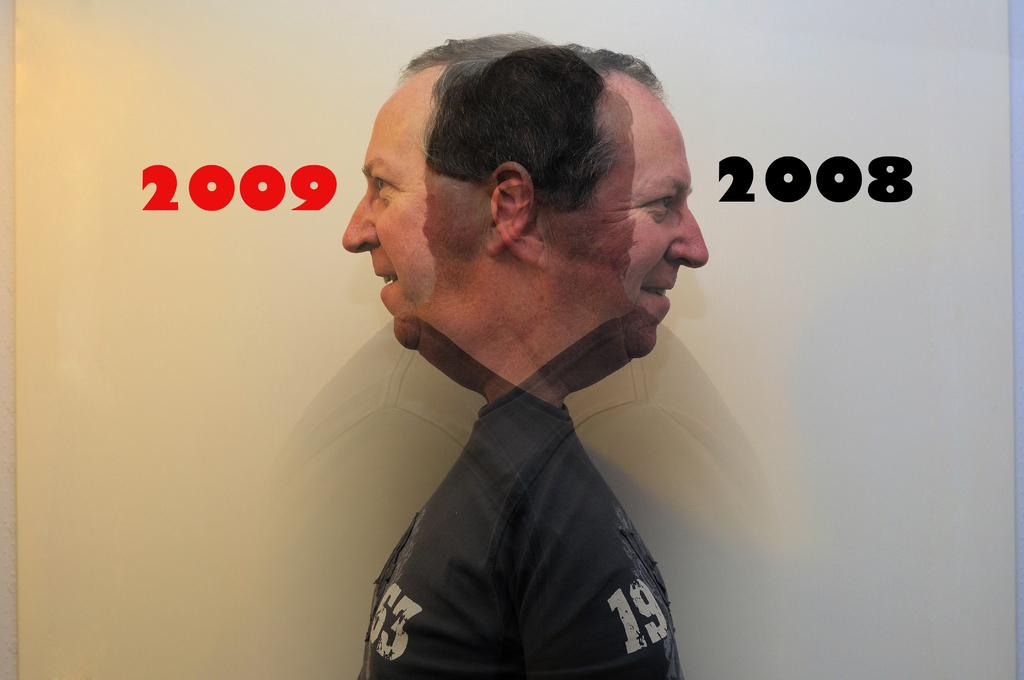What is the main subject of the image? There is a person in the image. What can be seen in the background of the image? There is a wall in the background of the image. Are there any specific details on the image? Yes, there are numbers on the image. What type of liquid can be seen dripping from the person's hand in the image? There is no liquid visible in the image, and the person's hand is not shown dripping anything. 